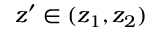<formula> <loc_0><loc_0><loc_500><loc_500>z ^ { \prime } \in ( z _ { 1 } , z _ { 2 } )</formula> 